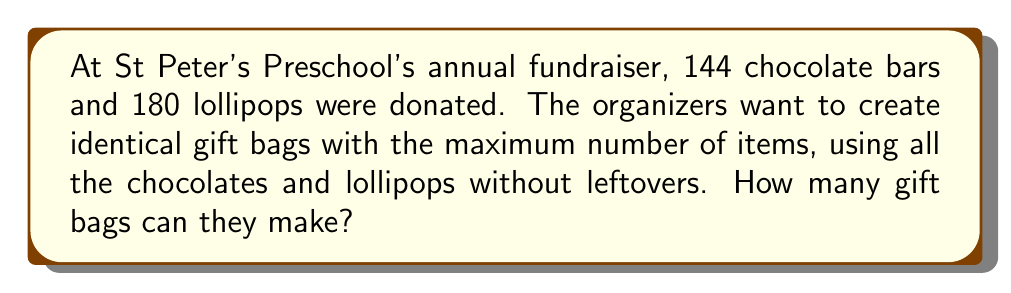Teach me how to tackle this problem. To solve this problem, we need to find the greatest common divisor (GCD) of 144 and 180 using the Euclidean algorithm. This will give us the maximum number of gift bags that can be created.

Let's apply the Euclidean algorithm:

1) First, divide 180 by 144:
   $180 = 1 \times 144 + 36$

2) Now, divide 144 by 36:
   $144 = 4 \times 36 + 0$

3) The process stops here as we've reached a remainder of 0.

The last non-zero remainder is 36, so the GCD of 144 and 180 is 36.

This means the organizers can create 36 identical gift bags.

To verify:
- Each bag will contain $144 \div 36 = 4$ chocolate bars
- Each bag will contain $180 \div 36 = 5$ lollipops

$$\text{Total items per bag} = 4 + 5 = 9$$

Therefore, 36 gift bags can be made, each containing 4 chocolate bars and 5 lollipops, using all the donated items without any leftovers.
Answer: 36 